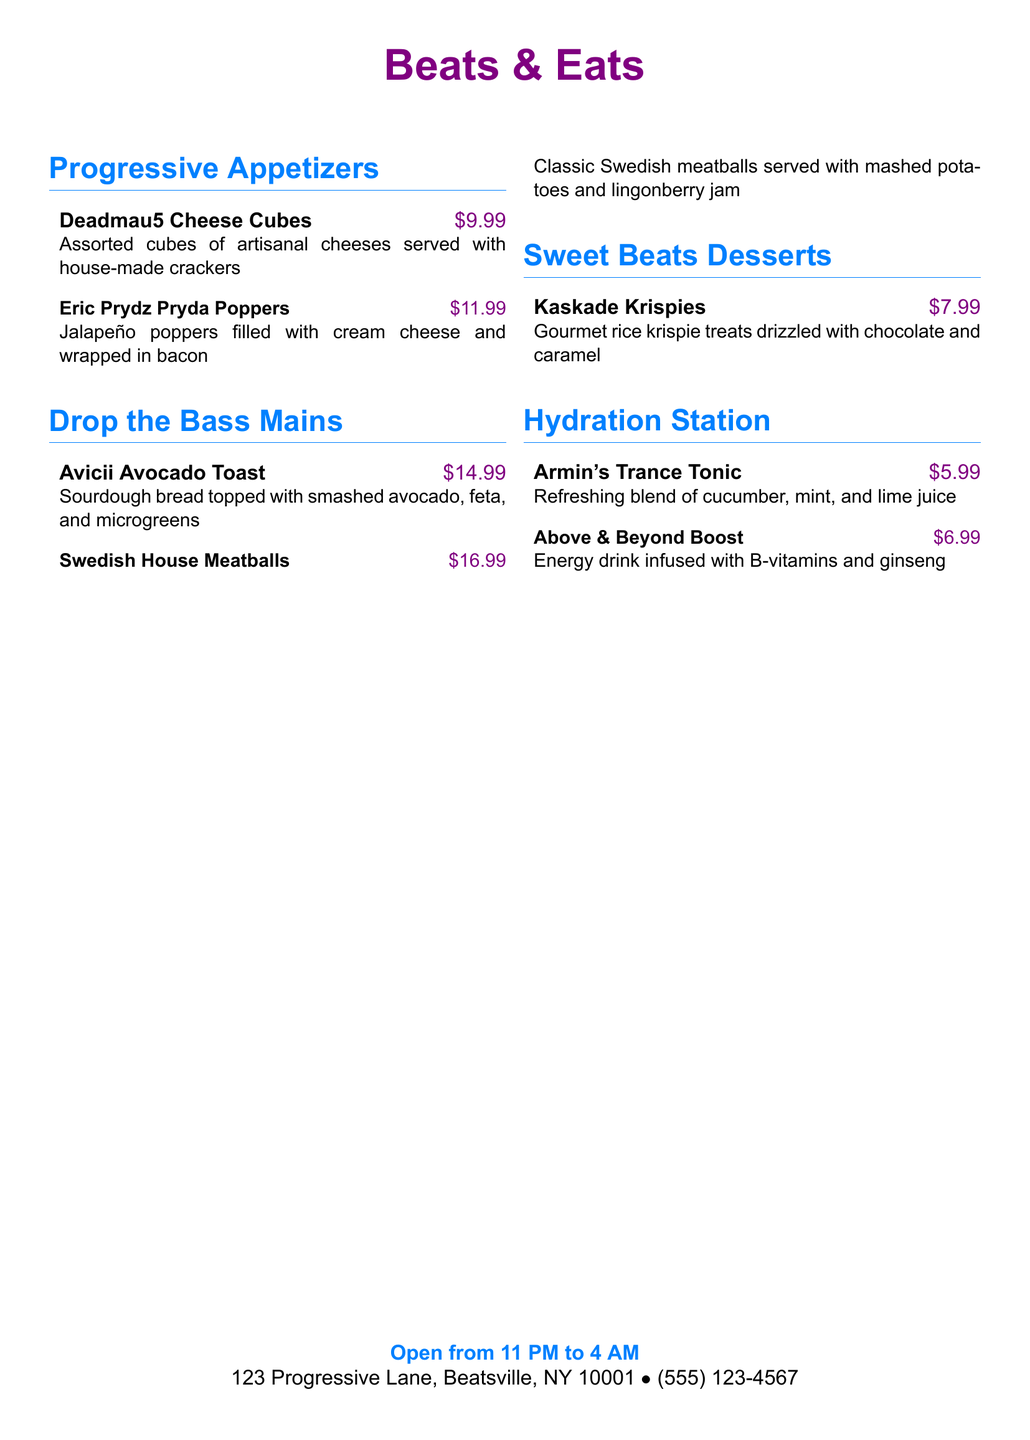What are the opening hours? The document provides the opening hours at the bottom, stating they are open from 11 PM to 4 AM.
Answer: 11 PM to 4 AM What is the price of Eric Prydz Pryda Poppers? The price of Eric Prydz Pryda Poppers is listed next to the menu item.
Answer: $11.99 How many appetizers are listed? The number of appetizers can be counted from the "Progressive Appetizers" section in the menu.
Answer: 2 What is the name of the dessert item? The document lists a dessert in the "Sweet Beats Desserts" section, which can be identified.
Answer: Kaskade Krispies What drink is infused with ginseng? The menu states that the drink infused with ginseng is listed under "Hydration Station."
Answer: Above & Beyond Boost What is the total number of main dishes? The main dishes can be counted from the "Drop the Bass Mains" section of the menu.
Answer: 2 What type of cheese is served in Deadmau5 Cheese Cubes? The description identifies that assorted cubes of artisanal cheeses are included in the dish.
Answer: Artisanal cheeses Which appetizer has bacon in it? The dish that contains bacon can be identified by reading the descriptions within the appetizer section.
Answer: Eric Prydz Pryda Poppers What is the price of the Avicii Avocado Toast? The price for the Avicii Avocado Toast can be found next to its name in the menu.
Answer: $14.99 